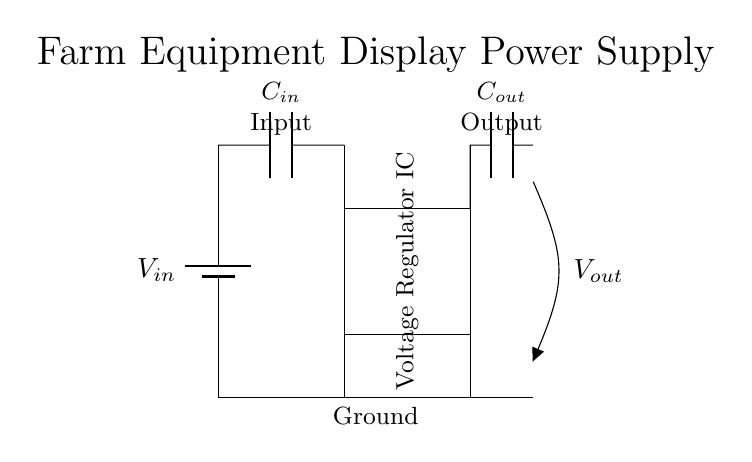What component is used to stabilize output voltage? The component used to stabilize the output voltage is a voltage regulator IC, which is represented in the diagram as a rectangle labeled 'Voltage Regulator IC'.
Answer: Voltage Regulator IC What are the values of the input and output capacitors? The values of the capacitors are indicated in the diagram. They are labeled as 'C in' for the input capacitor and 'C out' for the output capacitor. The diagram does not specify numerical values but they can be determined as needed when designing a circuit.
Answer: C in, C out Which connection represents ground in this circuit? The ground connection in the circuit is represented by the line at the bottom extending horizontally across the diagram. It connects multiple components, indicating a common reference point.
Answer: Bottom horizontal line What is the function of the input capacitor? The input capacitor, labeled 'C in', serves to filter and stabilize the input voltage to the voltage regulator, smoothing out voltage fluctuations that could affect its performance.
Answer: Filter input voltage How does the voltage regulator affect the output voltage? The voltage regulator ensures that the output voltage remains stable and within a specific range, regardless of variations in the input voltage or load current. This is crucial for farm equipment displays, which require consistent power for accurate readings.
Answer: Provides stable voltage What labels indicate the input and output of the circuit? The diagram clearly labels the input and output with the words 'Input' and 'Output', placed directly above the respective terminals where connections occur. These labels help easily identify the flow of voltage through the circuit.
Answer: Input, Output 